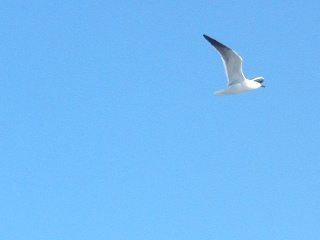Create a fictional scenario imagining that the bird is on a special mission. The bird in the image is not just any bird; it is a messenger for an ancient coastal tribe. It carries a small scroll tied to its leg with a message of great importance. The tribe, known for its deep connection with nature and the sea, has discovered a new treasure hidden in an old shipwreck. This bird's mission is to deliver the news to the chief's distant relative in a neighboring village, warning them of the storm that might claim the treasure if not retrieved in time. With every flap of its wings, the urgency of the message beats stronger, as skies clear the path for its destined journey. 